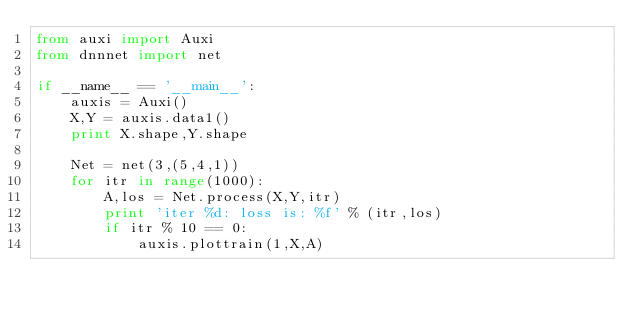<code> <loc_0><loc_0><loc_500><loc_500><_Python_>from auxi import Auxi
from dnnnet import net

if __name__ == '__main__':
    auxis = Auxi()
    X,Y = auxis.data1()
    print X.shape,Y.shape
 
    Net = net(3,(5,4,1))
    for itr in range(1000):
        A,los = Net.process(X,Y,itr)
        print 'iter %d: loss is: %f' % (itr,los)
        if itr % 10 == 0:
            auxis.plottrain(1,X,A)
</code> 